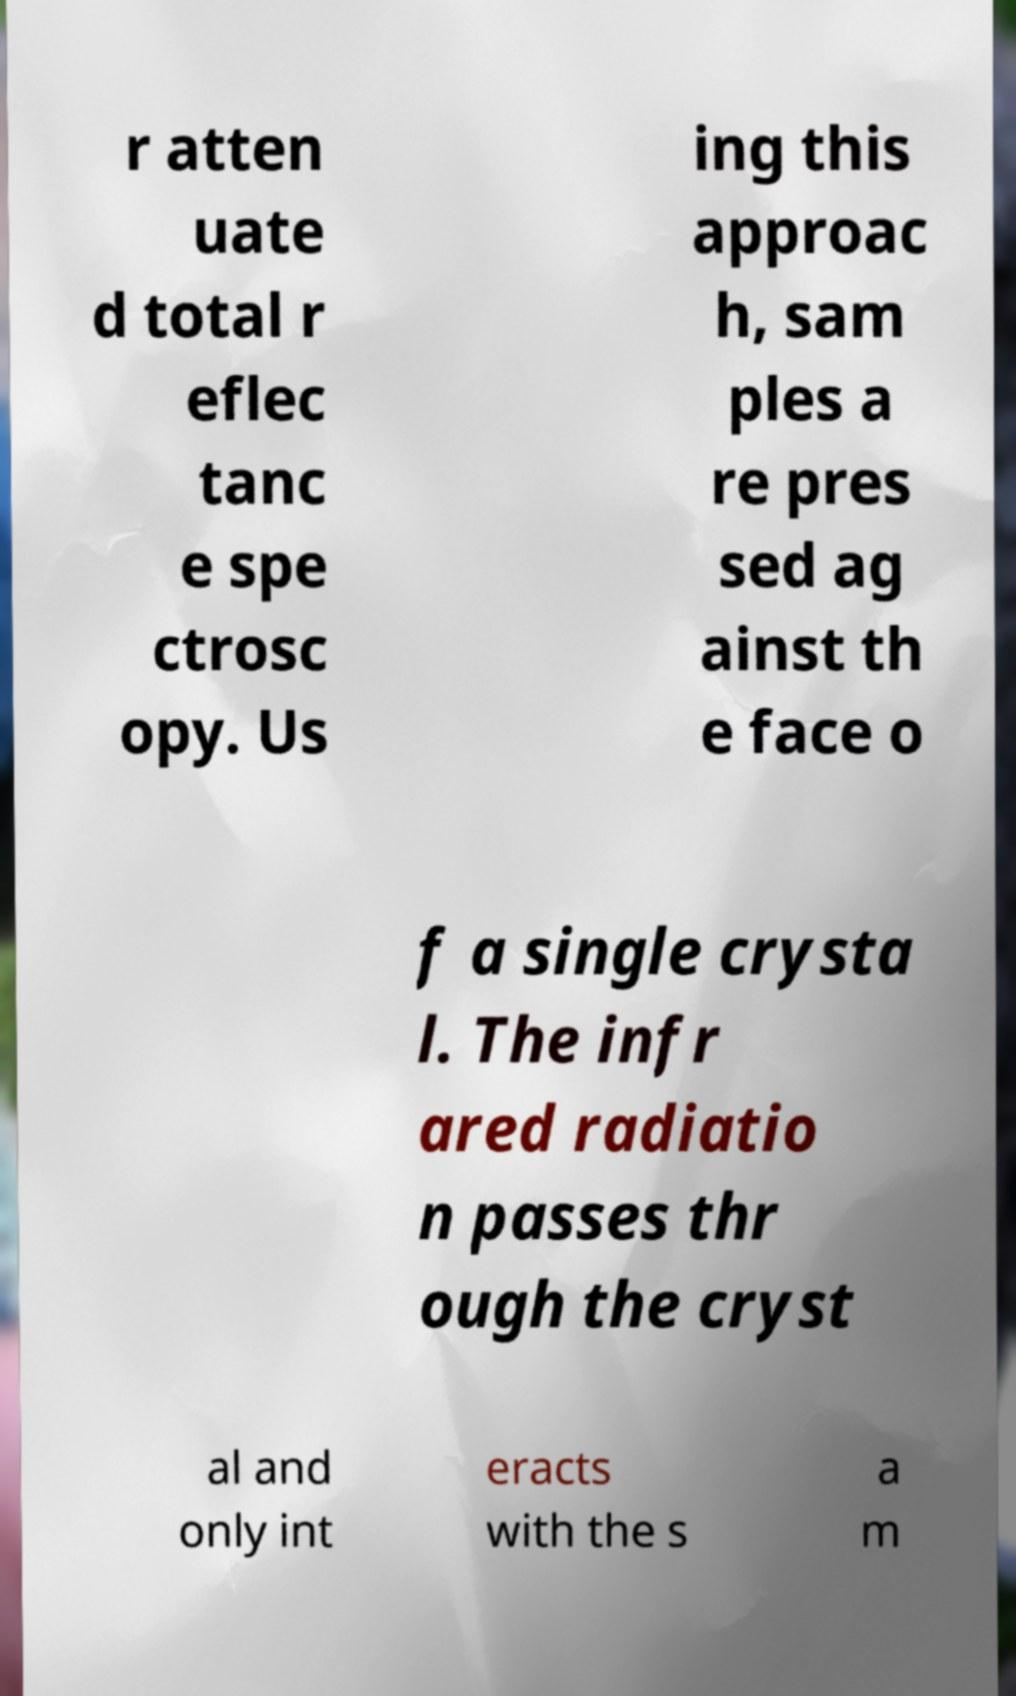I need the written content from this picture converted into text. Can you do that? r atten uate d total r eflec tanc e spe ctrosc opy. Us ing this approac h, sam ples a re pres sed ag ainst th e face o f a single crysta l. The infr ared radiatio n passes thr ough the cryst al and only int eracts with the s a m 